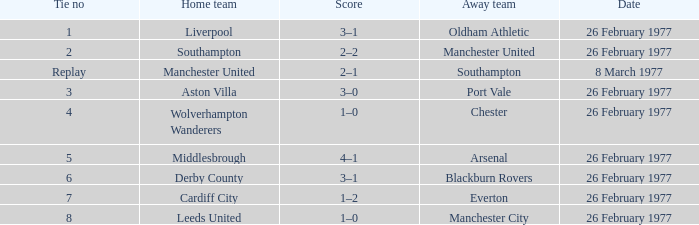On which date was chester the visiting team? 26 February 1977. 